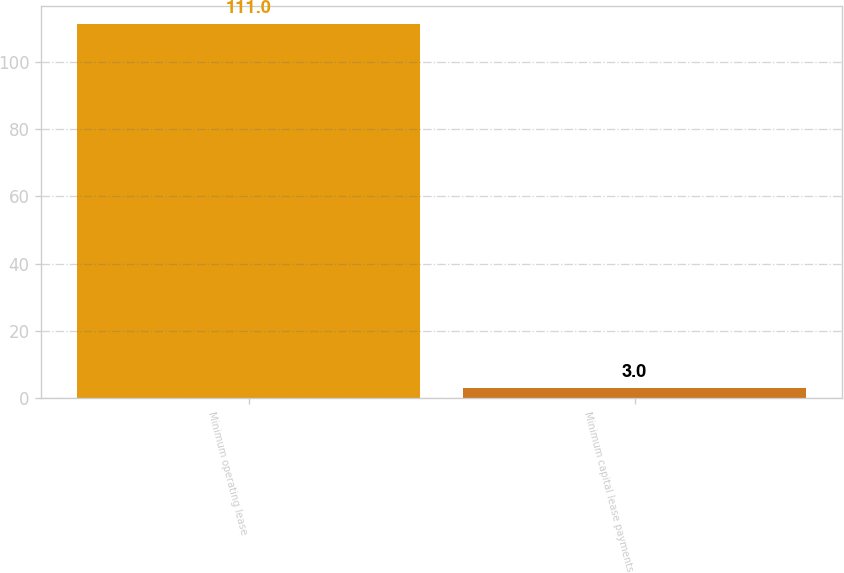Convert chart to OTSL. <chart><loc_0><loc_0><loc_500><loc_500><bar_chart><fcel>Minimum operating lease<fcel>Minimum capital lease payments<nl><fcel>111<fcel>3<nl></chart> 